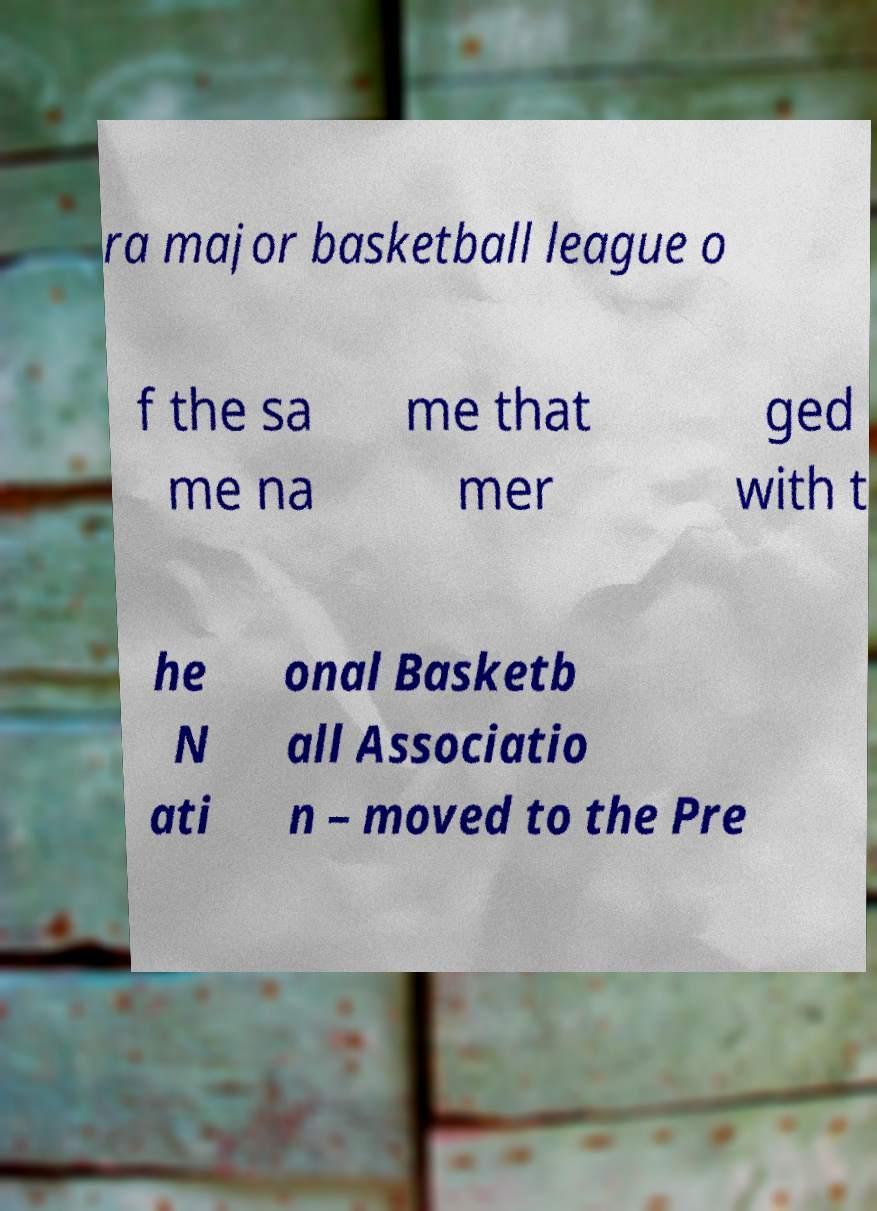Could you assist in decoding the text presented in this image and type it out clearly? ra major basketball league o f the sa me na me that mer ged with t he N ati onal Basketb all Associatio n – moved to the Pre 